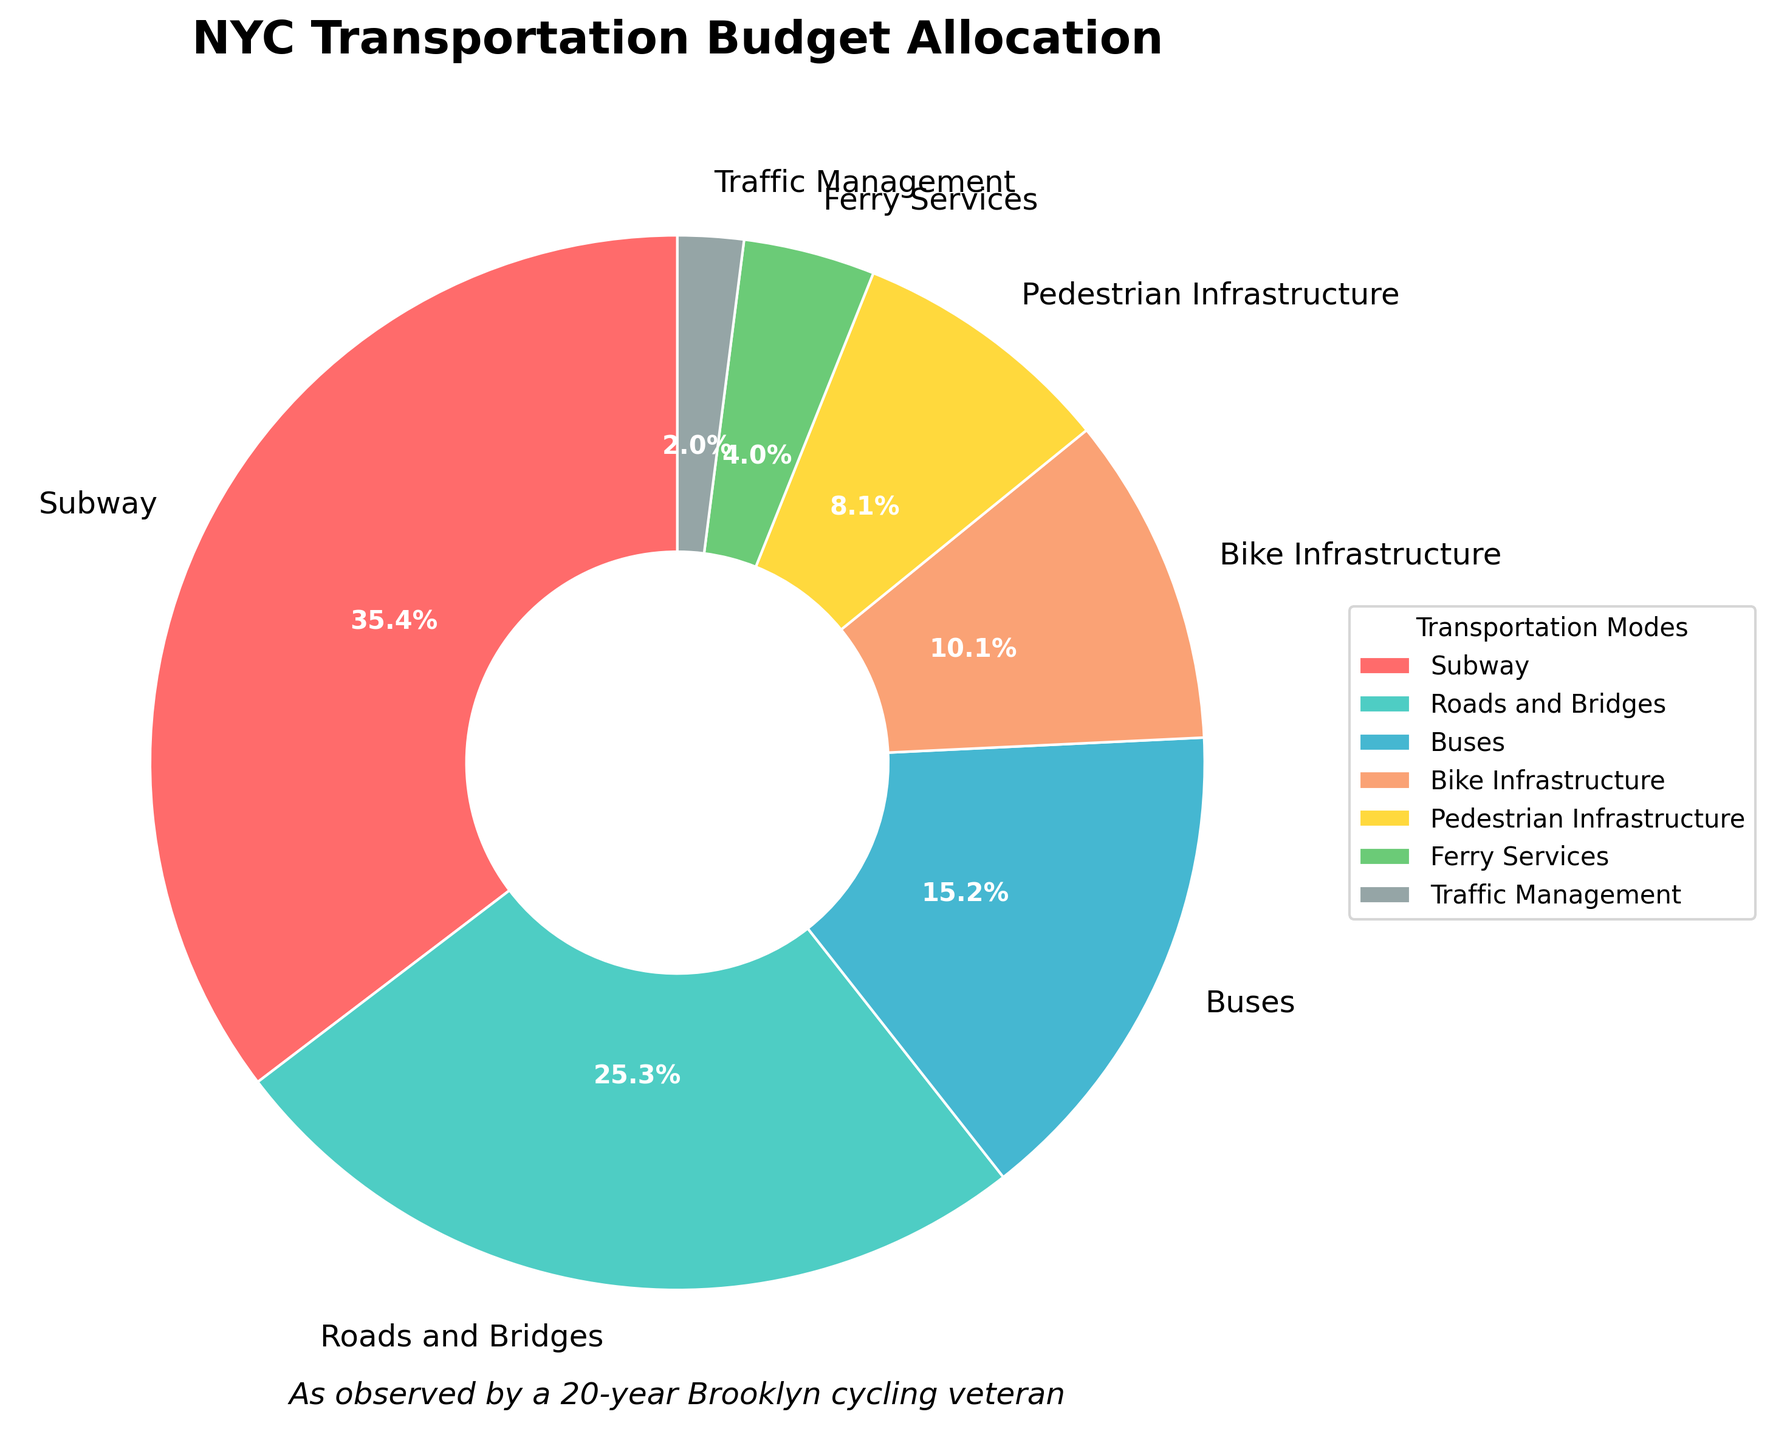What's the largest portion of the transportation budget allocated to? To determine the largest portion of the transportation budget, we look at the categories in the pie chart and identify the one with the highest percentage. The 'Subway' has the largest allocation at 35%.
Answer: Subway What's the combined budget allocation for Bike Infrastructure and Buses? Add the percentages of Bike Infrastructure (10%) and Buses (15%) to find the total allocated to both categories. 10% + 15% = 25%.
Answer: 25% How does the allocation for Pedestrian Infrastructure compare to that of Ferry Services? Compare the two percentages in the pie chart for Pedestrian Infrastructure (8%) and Ferry Services (4%). Pedestrian Infrastructure has a higher allocation than Ferry Services.
Answer: Pedestrian Infrastructure has a higher allocation Is the allocation for Roads and Bridges greater than the allocation for Buses and Bike Infrastructure combined? The allocation for Roads and Bridges is 25%. Combine the allocations for Buses (15%) and Bike Infrastructure (10%) which totals 25%. Both are equal.
Answer: No, they are equal What percentage of the budget is allocated to Traffic Management? Check the pie chart segment labeled 'Traffic Management', which shows an allocation of 2%.
Answer: 2% What two categories have the smallest budget allocations? Identify the two smallest segments in the pie chart. They belong to Ferry Services (4%) and Traffic Management (2%).
Answer: Ferry Services and Traffic Management What's the total percentage allocated to infrastructure that supports non-motorized transport (Bike and Pedestrian Infrastructure)? Add the percentages for Bike Infrastructure (10%) and Pedestrian Infrastructure (8%). 10% + 8% = 18%.
Answer: 18% By how much does the budget allocation for the Subway exceed the allocation for Buses? Subtract the allocation for Buses (15%) from the allocation for the Subway (35%). 35% - 15% = 20%.
Answer: 20% Which mode of transportation has an allocation that is less than Pedestrian Infrastructure but more than Traffic Management? Pedestrian Infrastructure is allocated 8% and Traffic Management 2%. The mode that fits between these is Ferry Services at 4%.
Answer: Ferry Services 